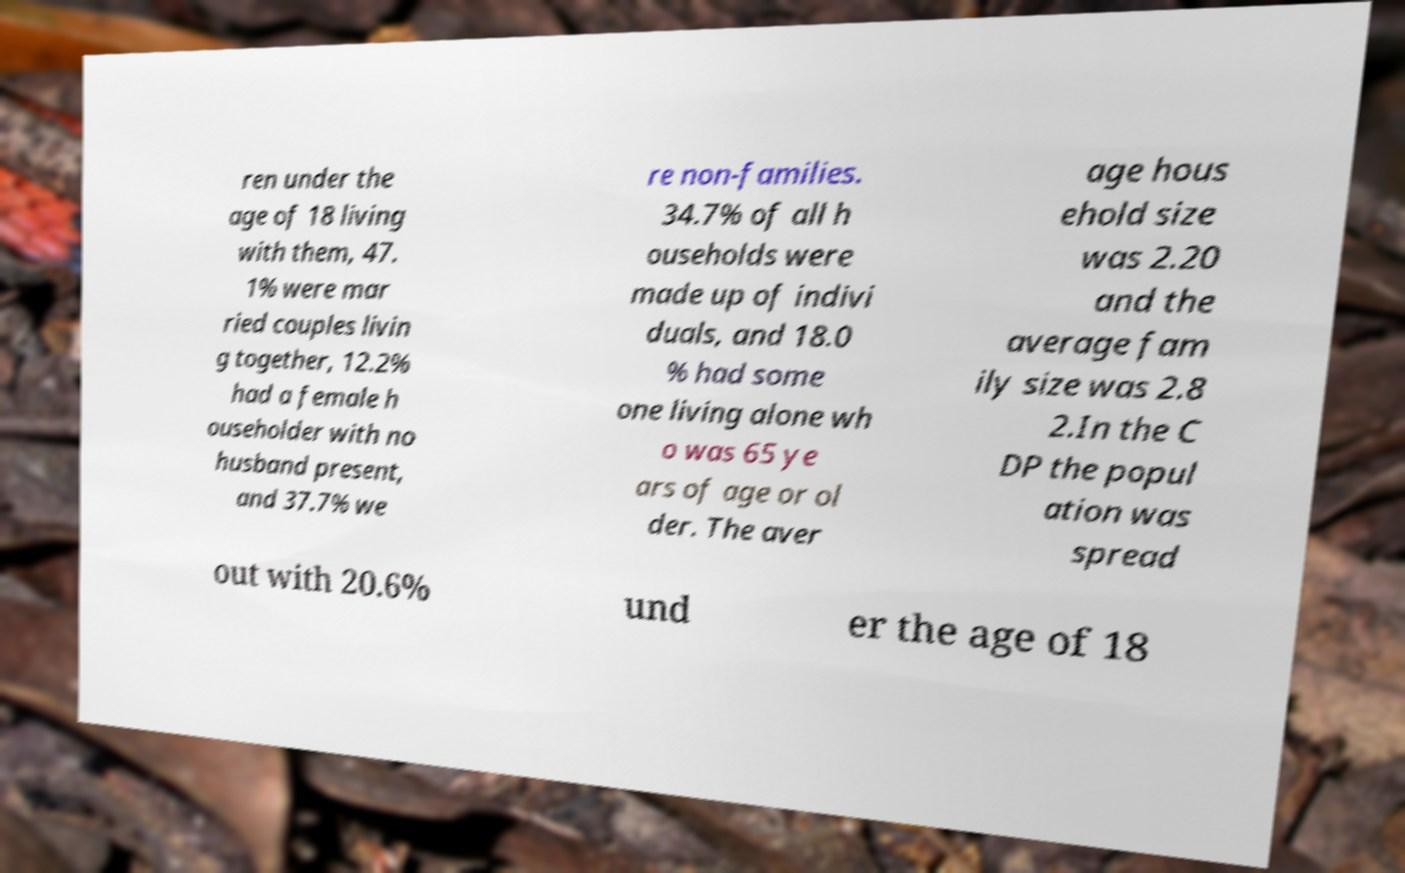Can you read and provide the text displayed in the image?This photo seems to have some interesting text. Can you extract and type it out for me? ren under the age of 18 living with them, 47. 1% were mar ried couples livin g together, 12.2% had a female h ouseholder with no husband present, and 37.7% we re non-families. 34.7% of all h ouseholds were made up of indivi duals, and 18.0 % had some one living alone wh o was 65 ye ars of age or ol der. The aver age hous ehold size was 2.20 and the average fam ily size was 2.8 2.In the C DP the popul ation was spread out with 20.6% und er the age of 18 